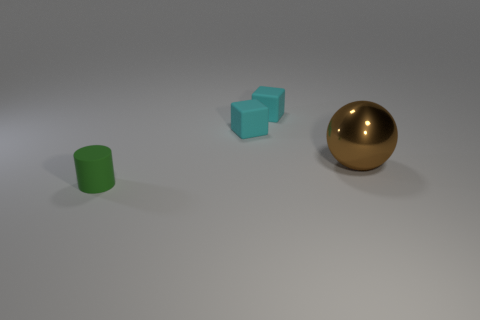Add 3 matte objects. How many objects exist? 7 Add 2 gray matte things. How many gray matte things exist? 2 Subtract 0 green cubes. How many objects are left? 4 Subtract all cylinders. How many objects are left? 3 Subtract all yellow balls. Subtract all gray cylinders. How many balls are left? 1 Subtract all red balls. How many purple blocks are left? 0 Subtract all big cyan matte things. Subtract all matte cylinders. How many objects are left? 3 Add 2 small green matte things. How many small green matte things are left? 3 